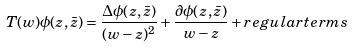<formula> <loc_0><loc_0><loc_500><loc_500>T ( w ) \phi ( z , \bar { z } ) = \frac { \Delta \phi ( z , \bar { z } ) } { ( w - z ) ^ { 2 } } + \frac { \partial \phi ( z , \bar { z } ) } { w - z } + r e g u l a r t e r m s</formula> 